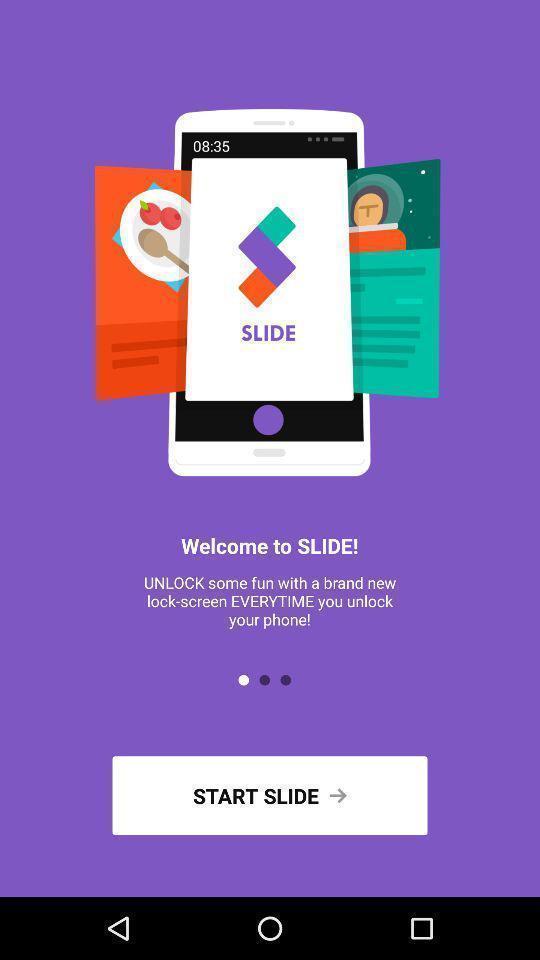What can you discern from this picture? Welcome page of social app. 